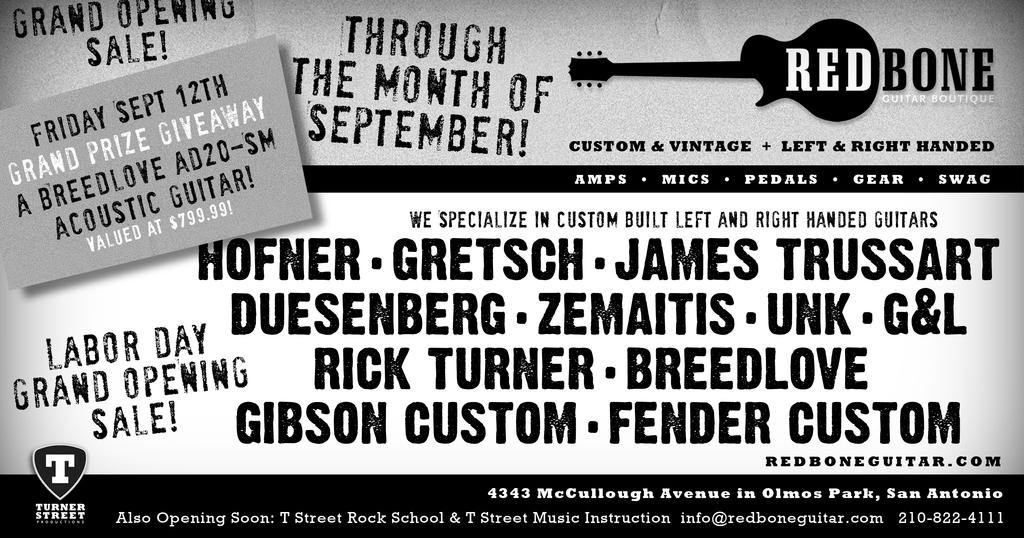What is the main object in the image? There is a pamphlet in the image. What colors are used in the pamphlet? The pamphlet is in black, white, and ash colors. What can be found on the pamphlet? There is writing on the pamphlet. What symbol is present on the pamphlet? There is a symbol of a guitar on the pamphlet. How does the stomach of the person holding the pamphlet look in the image? There is no person holding the pamphlet in the image, so we cannot see their stomach. Can you compare the size of the guitar symbol on the pamphlet to the size of a real guitar? We cannot make a comparison between the size of the guitar symbol on the pamphlet and a real guitar, as we do not have a reference for the size of the symbol in the image. 